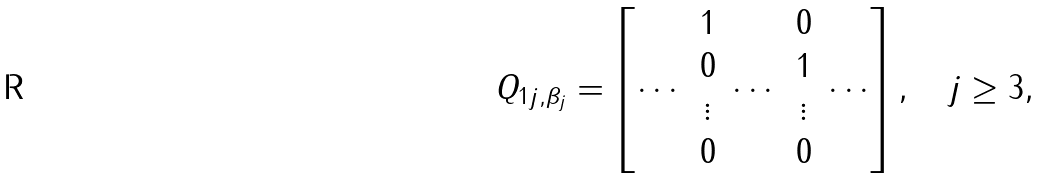<formula> <loc_0><loc_0><loc_500><loc_500>& Q _ { 1 j , \beta _ { j } } = \begin{bmatrix} \cdots & \begin{matrix} 1 \\ 0 \\ \vdots \\ 0 \end{matrix} & \cdots & \begin{matrix} 0 \\ 1 \\ \vdots \\ 0 \end{matrix} & \cdots \end{bmatrix} , \quad j \geq 3 ,</formula> 